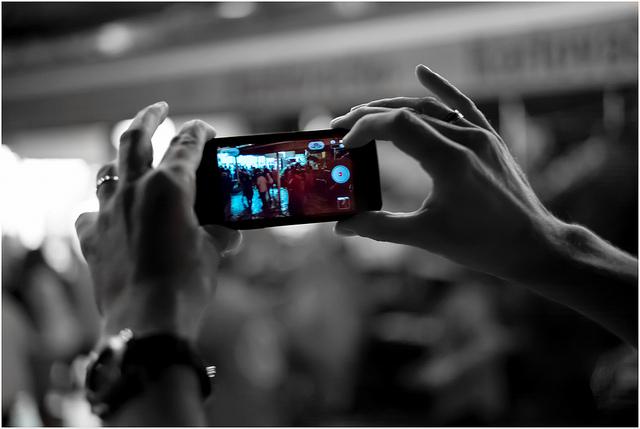Is this picture partially black and white?
Answer briefly. Yes. What is the person doing?
Write a very short answer. Taking picture. Is this person married?
Give a very brief answer. Yes. 